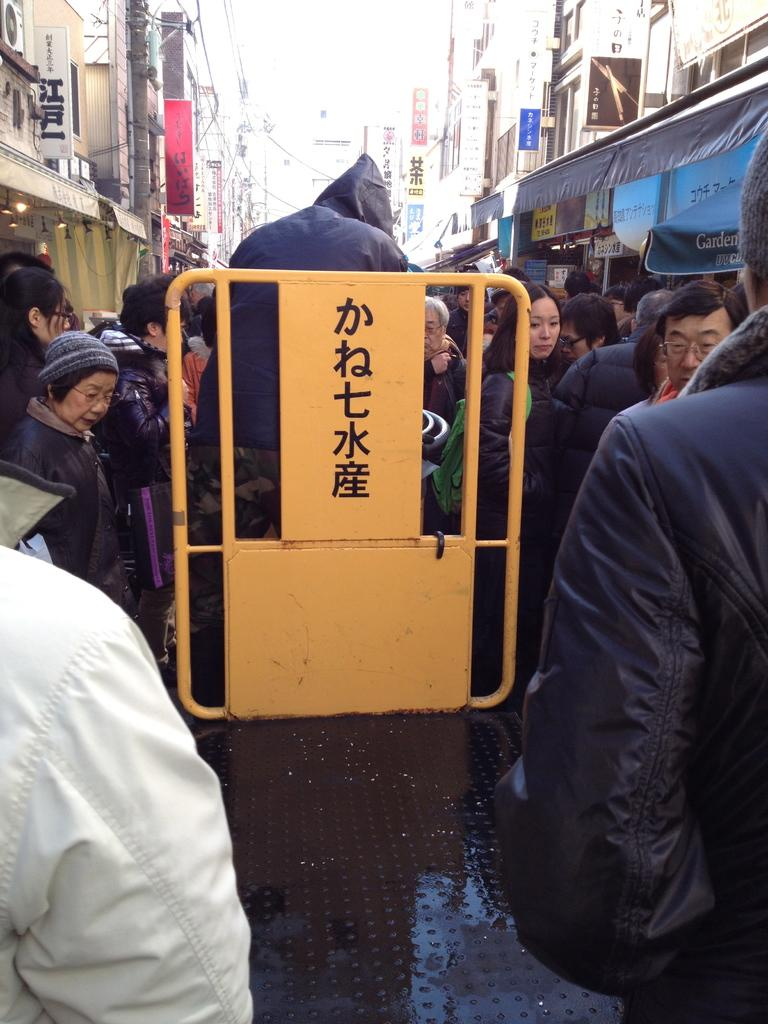Who or what can be seen in the image? There are people in the image. What is the board in the image used for? The purpose of the board in the image is not specified, but it could be a sign or notice board. What can be seen in the distance in the image? There are buildings and a hoarding in the background of the image. What are the people in the image wearing? The people in the image are wearing jackets. What type of trees can be seen in the image? There are no trees visible in the image. How do the people in the image express their anger? The image does not show any indication of anger or emotion from the people in the image. 